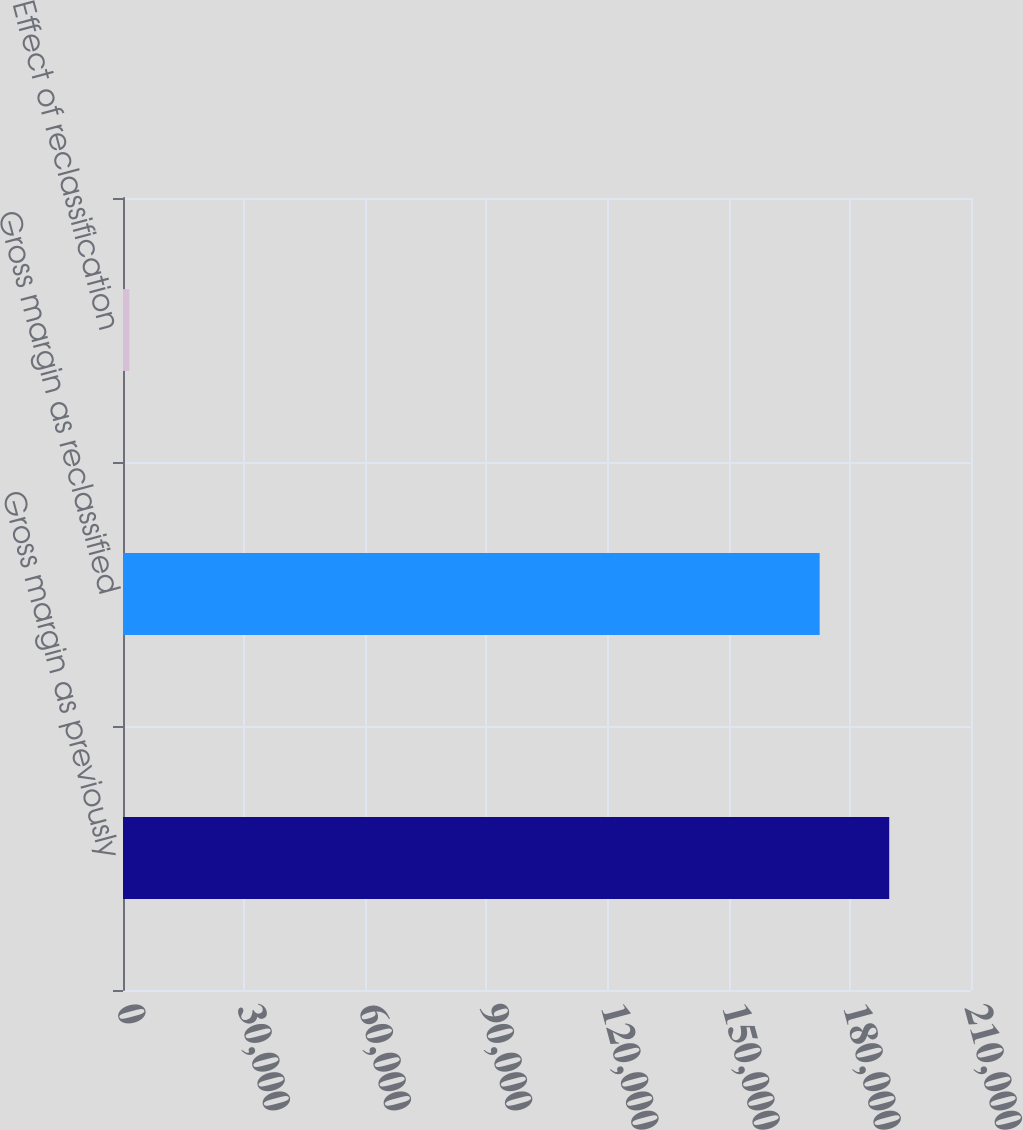Convert chart. <chart><loc_0><loc_0><loc_500><loc_500><bar_chart><fcel>Gross margin as previously<fcel>Gross margin as reclassified<fcel>Effect of reclassification<nl><fcel>189748<fcel>172524<fcel>1579<nl></chart> 